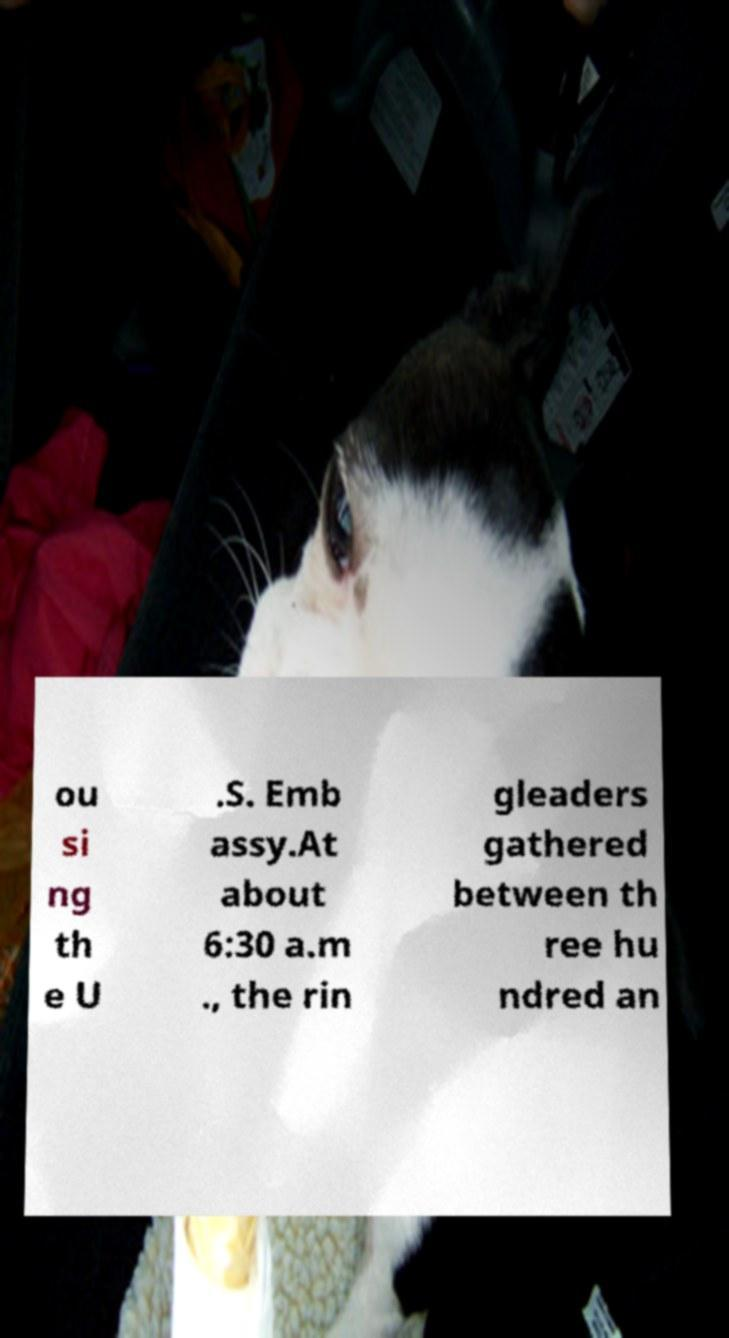Please identify and transcribe the text found in this image. ou si ng th e U .S. Emb assy.At about 6:30 a.m ., the rin gleaders gathered between th ree hu ndred an 